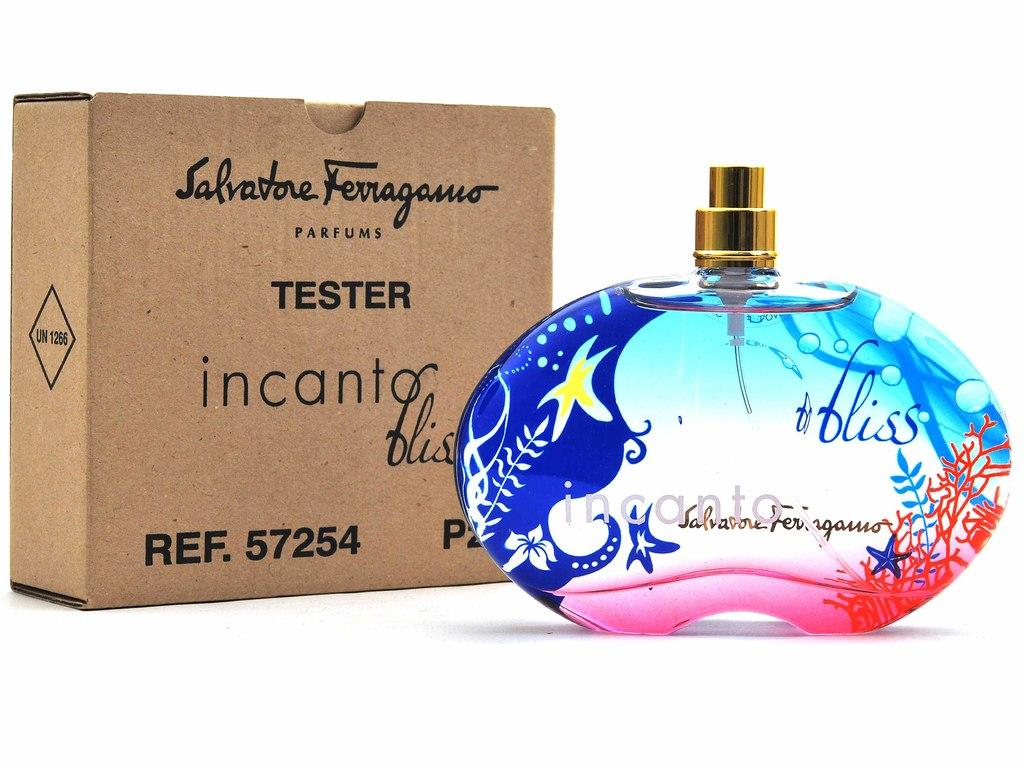Provide a one-sentence caption for the provided image. The incanto bliss perfume bottle is decorated with starfish , ferns and coral. 